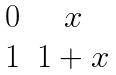<formula> <loc_0><loc_0><loc_500><loc_500>\begin{matrix} 0 & x \\ 1 & 1 + x \end{matrix}</formula> 